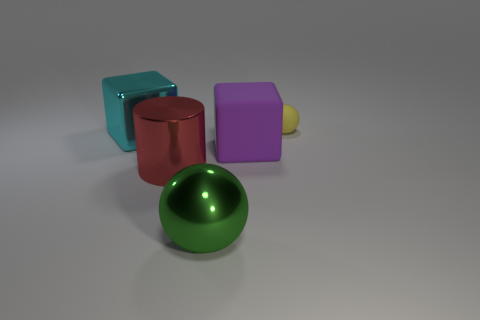There is a large purple thing that is the same shape as the cyan thing; what is its material?
Ensure brevity in your answer.  Rubber. There is a cylinder that is made of the same material as the green ball; what is its size?
Your answer should be compact. Large. Does the yellow object have the same shape as the large green object?
Your answer should be very brief. Yes. How many small yellow objects have the same shape as the big matte object?
Your answer should be compact. 0. There is a object that is behind the large block that is to the left of the purple cube; what size is it?
Offer a very short reply. Small. What number of purple things are either small objects or rubber things?
Offer a terse response. 1. Is the number of big purple blocks that are left of the red object less than the number of yellow objects behind the large green metallic ball?
Keep it short and to the point. Yes. Is the size of the red thing the same as the ball in front of the cyan object?
Your response must be concise. Yes. What number of other objects are the same size as the cyan metallic object?
Your response must be concise. 3. How many small objects are metallic spheres or cyan blocks?
Your response must be concise. 0. 